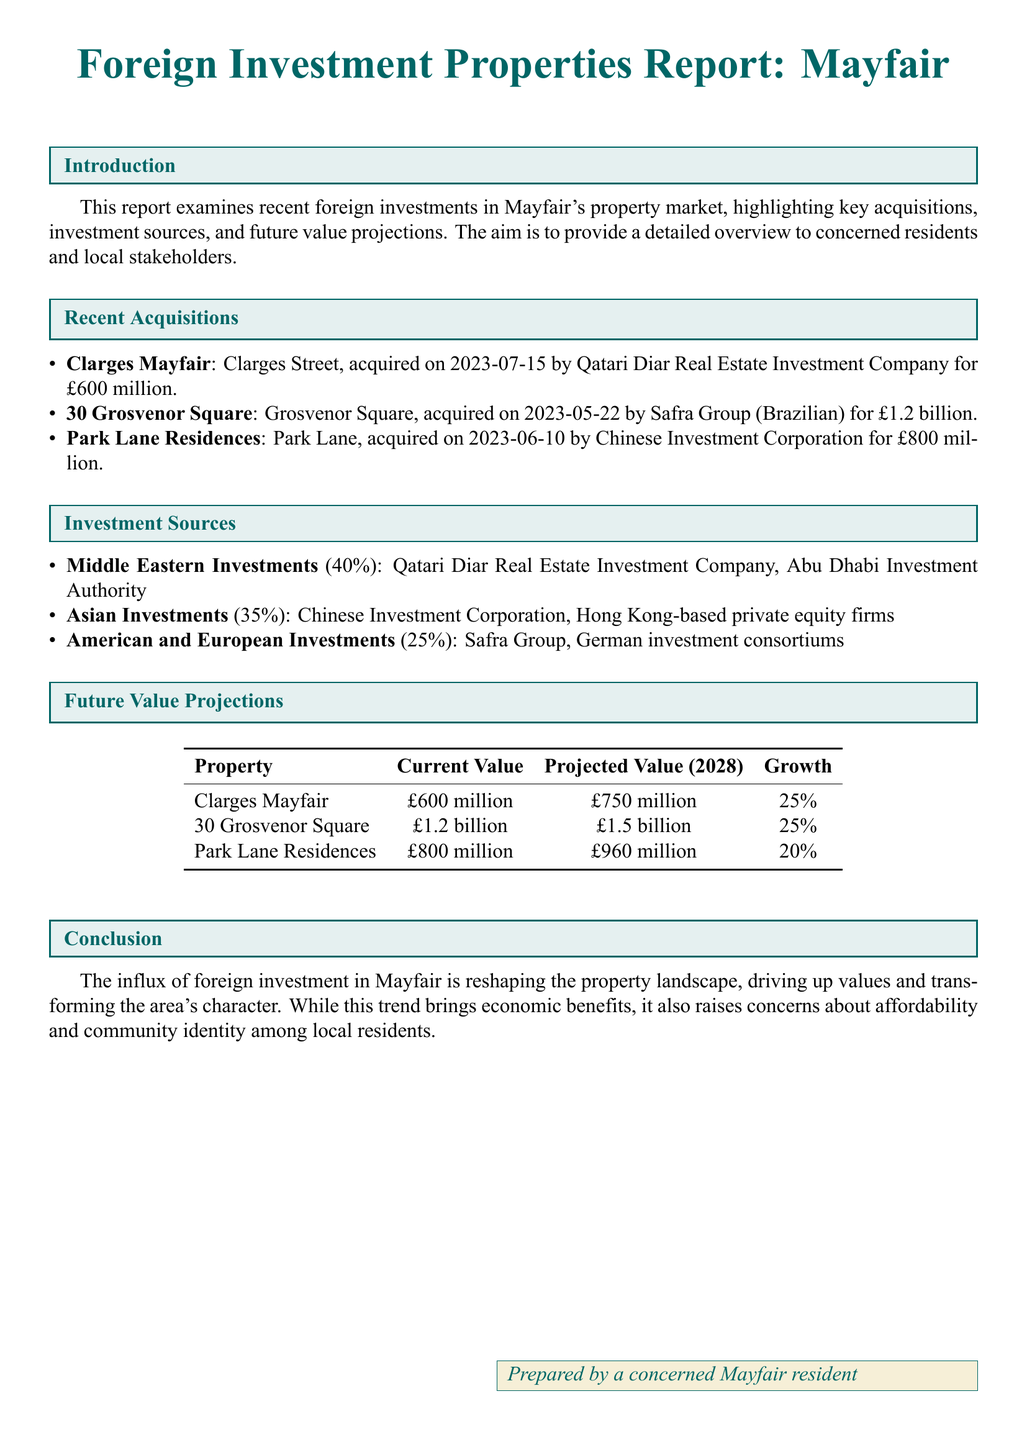What is the acquisition date of Clarges Mayfair? The acquisition date is explicitly mentioned in the document for Clarges Mayfair, which is 2023-07-15.
Answer: 2023-07-15 Who acquired 30 Grosvenor Square? The document specifies that 30 Grosvenor Square was acquired by the Safra Group, a Brazilian investment entity.
Answer: Safra Group What is the current value of Park Lane Residences? The document provides the current value of Park Lane Residences, which is £800 million.
Answer: £800 million What percentage of investments come from Middle Eastern sources? According to the document, the percentage of investments from Middle Eastern sources is explicitly stated as 40%.
Answer: 40% What is the projected value of Clarges Mayfair in 2028? The projected value for Clarges Mayfair in 2028 is mentioned as £750 million.
Answer: £750 million Which property has the highest projected growth percentage? The document indicates the property with the highest projected growth percentage is Clarges Mayfair and 30 Grosvenor Square, both at 25%.
Answer: Clarges Mayfair and 30 Grosvenor Square How much did the Chinese Investment Corporation pay for Park Lane Residences? The document lists the purchase price for Park Lane Residences, which is £800 million.
Answer: £800 million What is the total projected value for 30 Grosvenor Square? The total projected value for 30 Grosvenor Square in 2028 is referred to in the document, which is £1.5 billion.
Answer: £1.5 billion What does the report conclude about foreign investment's impact on community identity? The conclusion section of the document suggests concerns about community identity due to foreign investments reshaping the area.
Answer: Concerns about affordability and community identity 